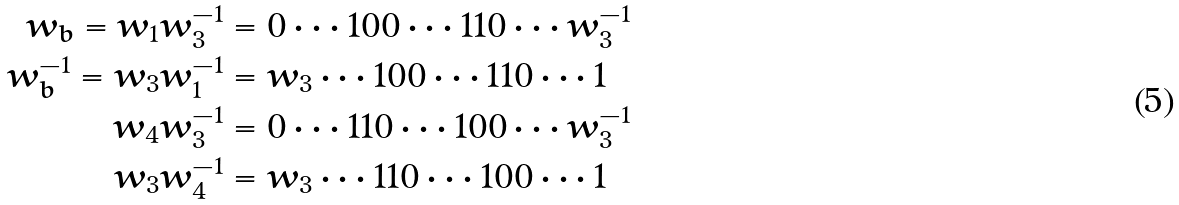<formula> <loc_0><loc_0><loc_500><loc_500>w _ { b } = w _ { 1 } w _ { 3 } ^ { - 1 } & = 0 \cdots 1 0 0 \cdots 1 1 0 \cdots w _ { 3 } ^ { - 1 } \\ w _ { b } ^ { - 1 } = w _ { 3 } w _ { 1 } ^ { - 1 } & = w _ { 3 } \cdots 1 0 0 \cdots 1 1 0 \cdots 1 \\ w _ { 4 } w _ { 3 } ^ { - 1 } & = 0 \cdots 1 1 0 \cdots 1 0 0 \cdots w _ { 3 } ^ { - 1 } \\ w _ { 3 } w _ { 4 } ^ { - 1 } & = w _ { 3 } \cdots 1 1 0 \cdots 1 0 0 \cdots 1</formula> 